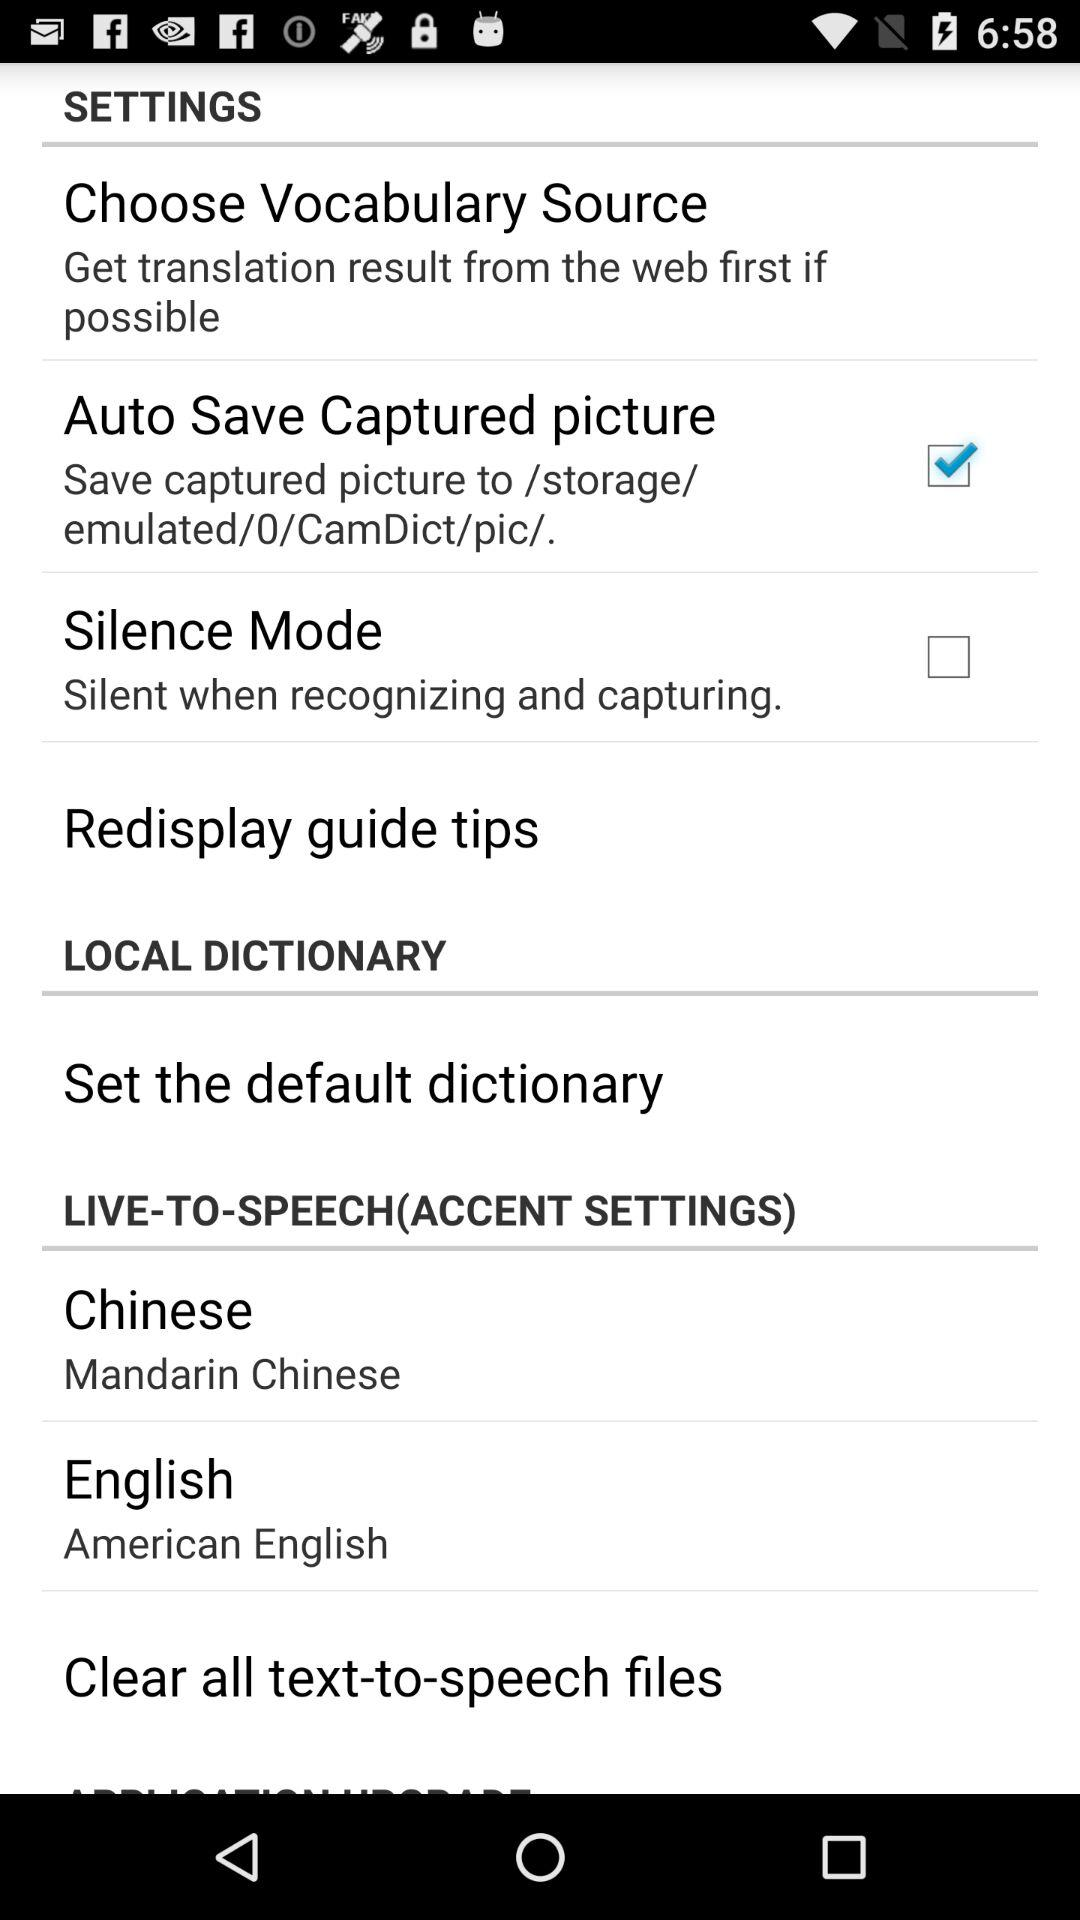What is the current status of "Silence Mode"? The current status of "Silence Mode" is "off". 